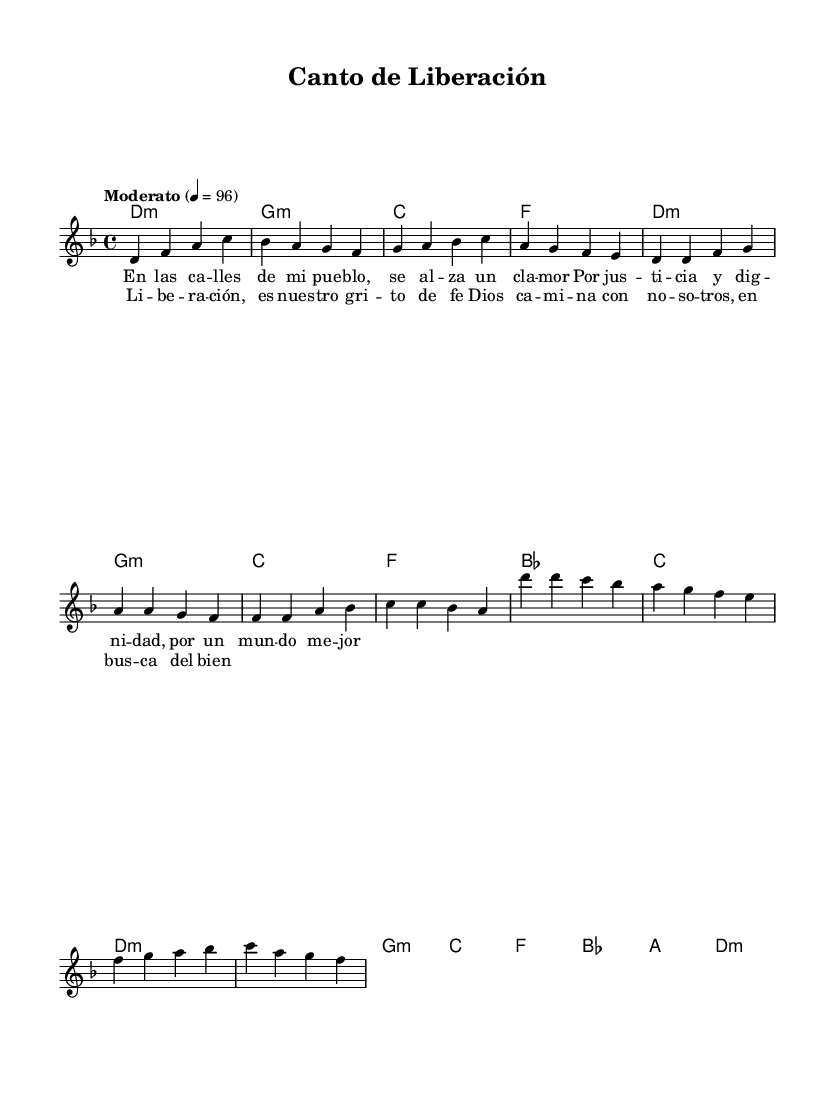What is the key signature of this music? The key signature is indicated at the beginning of the staff and shows one flat, which corresponds to D minor.
Answer: D minor What is the time signature of this music? The time signature is specified at the beginning of the score as four beats per measure, indicated with the 4/4 notation.
Answer: 4/4 What is the tempo marking of this music? The tempo marking is found at the top of the first measure and indicates a moderate speed of 96 beats per minute.
Answer: Moderato 4 = 96 What is the primary theme of the lyrics in the first verse? The lyrics suggest a theme of justice and dignity for the people, highlighting a desire for improvement in their lives.
Answer: Justice and dignity How many measures are there in the chorus section? The chorus is written in four measures as indicated by the layout of the music, with clear separations between each measure.
Answer: 4 How do the harmonies in the chorus differ from those in the verse? The harmonies change slightly in the chorus, notably by the movement to different chords such as moving to A major, while the verse primarily uses D minor and G minor.
Answer: Different chord progressions What cultural significance does this song represent? The song embodies Latin American liberation theology, emphasizing themes of social justice and faith within the context of a struggle for oppressed communities.
Answer: Social justice and faith 